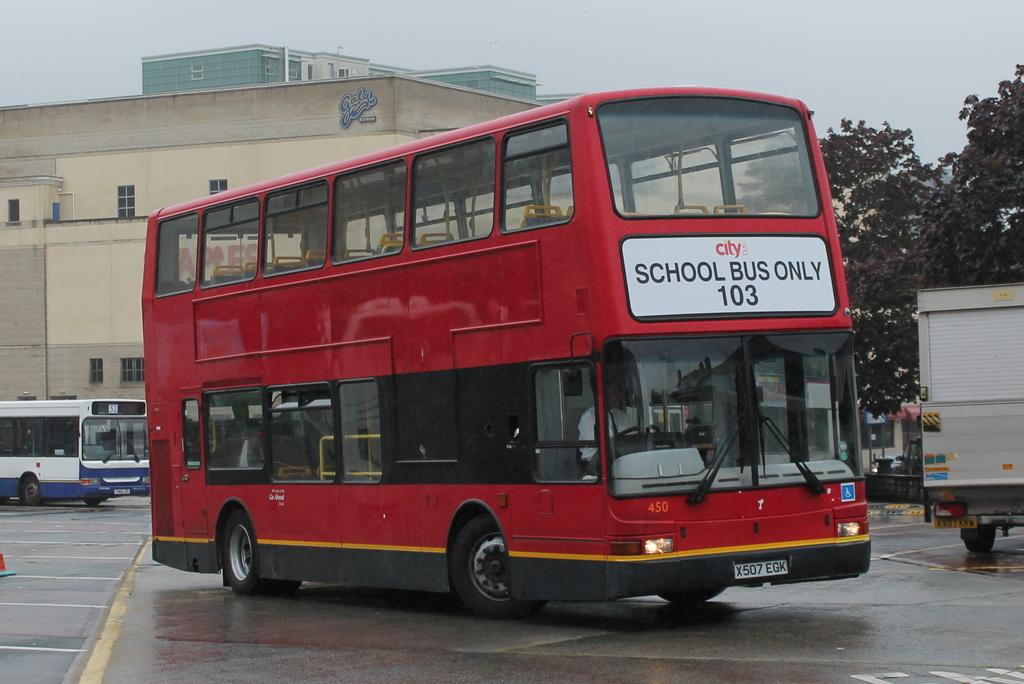<image>
Offer a succinct explanation of the picture presented. A red double-decker bus is serving as a school bus on the 103 route. 